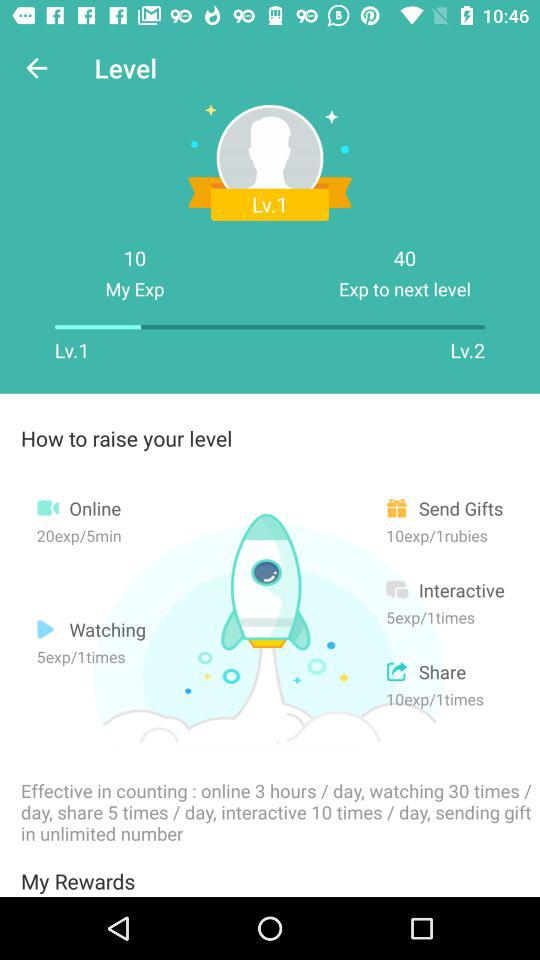Which activity is described as having 10 experience points for every ruby sent? The activity that is described as having 10 experience points for every ruby sent is "Send Gifts". 